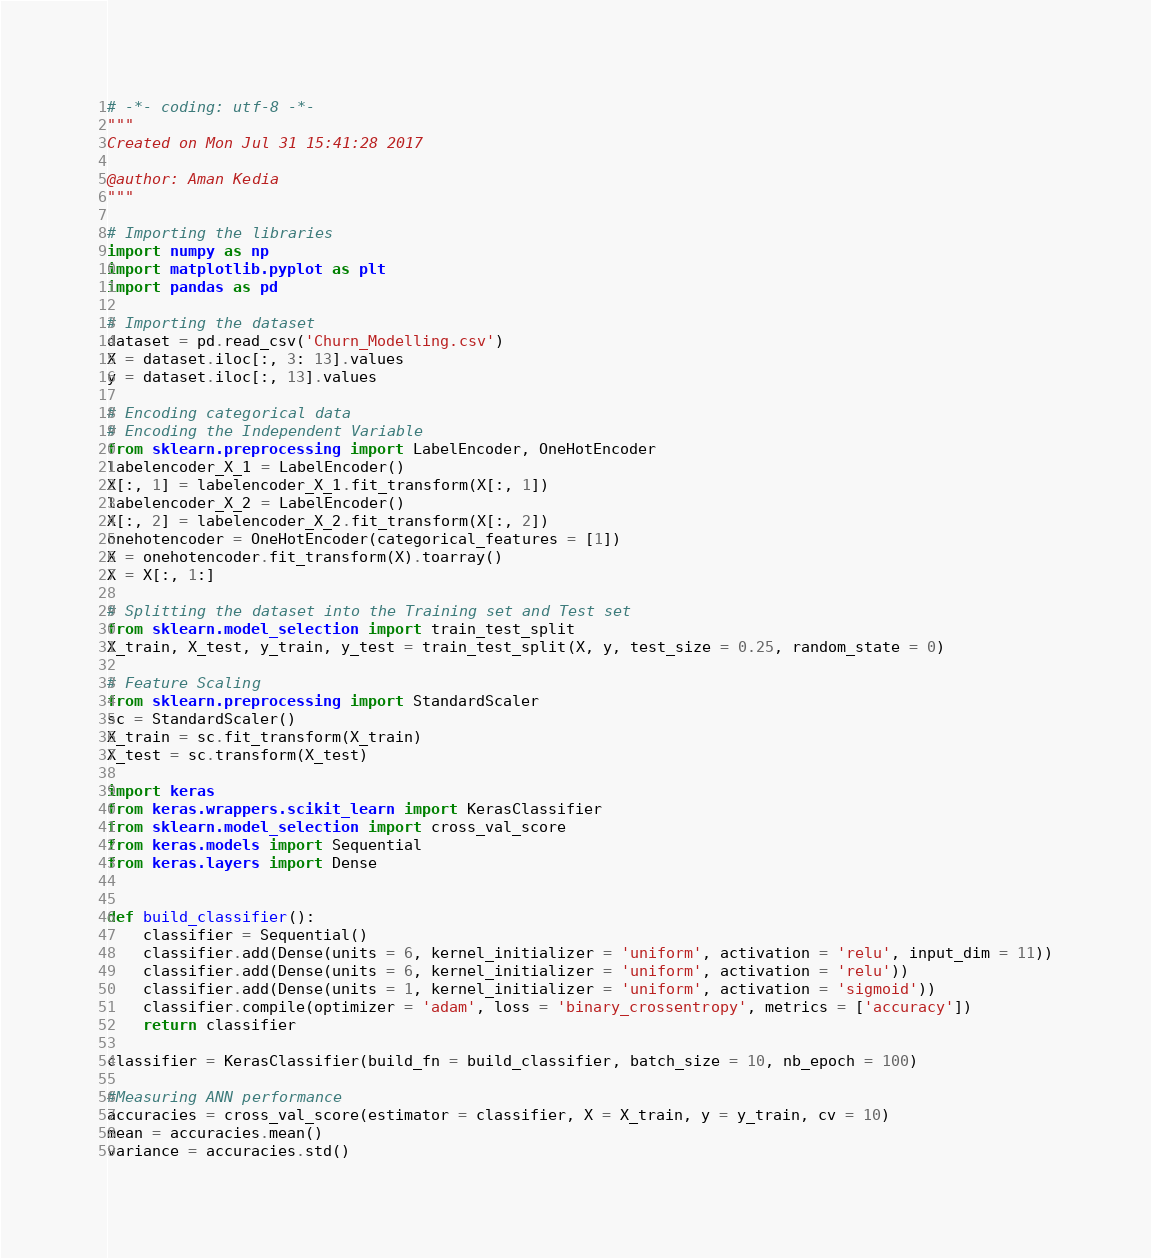Convert code to text. <code><loc_0><loc_0><loc_500><loc_500><_Python_># -*- coding: utf-8 -*-
"""
Created on Mon Jul 31 15:41:28 2017

@author: Aman Kedia
"""

# Importing the libraries
import numpy as np
import matplotlib.pyplot as plt
import pandas as pd

# Importing the dataset
dataset = pd.read_csv('Churn_Modelling.csv')
X = dataset.iloc[:, 3: 13].values
y = dataset.iloc[:, 13].values

# Encoding categorical data
# Encoding the Independent Variable
from sklearn.preprocessing import LabelEncoder, OneHotEncoder
labelencoder_X_1 = LabelEncoder()
X[:, 1] = labelencoder_X_1.fit_transform(X[:, 1])
labelencoder_X_2 = LabelEncoder()
X[:, 2] = labelencoder_X_2.fit_transform(X[:, 2])
onehotencoder = OneHotEncoder(categorical_features = [1])
X = onehotencoder.fit_transform(X).toarray()
X = X[:, 1:]

# Splitting the dataset into the Training set and Test set
from sklearn.model_selection import train_test_split
X_train, X_test, y_train, y_test = train_test_split(X, y, test_size = 0.25, random_state = 0)

# Feature Scaling
from sklearn.preprocessing import StandardScaler
sc = StandardScaler()
X_train = sc.fit_transform(X_train)
X_test = sc.transform(X_test)

import keras
from keras.wrappers.scikit_learn import KerasClassifier
from sklearn.model_selection import cross_val_score
from keras.models import Sequential
from keras.layers import Dense


def build_classifier():
    classifier = Sequential()
    classifier.add(Dense(units = 6, kernel_initializer = 'uniform', activation = 'relu', input_dim = 11))
    classifier.add(Dense(units = 6, kernel_initializer = 'uniform', activation = 'relu'))
    classifier.add(Dense(units = 1, kernel_initializer = 'uniform', activation = 'sigmoid'))
    classifier.compile(optimizer = 'adam', loss = 'binary_crossentropy', metrics = ['accuracy'])
    return classifier
    
classifier = KerasClassifier(build_fn = build_classifier, batch_size = 10, nb_epoch = 100)

#Measuring ANN performance
accuracies = cross_val_score(estimator = classifier, X = X_train, y = y_train, cv = 10)
mean = accuracies.mean()
variance = accuracies.std()</code> 